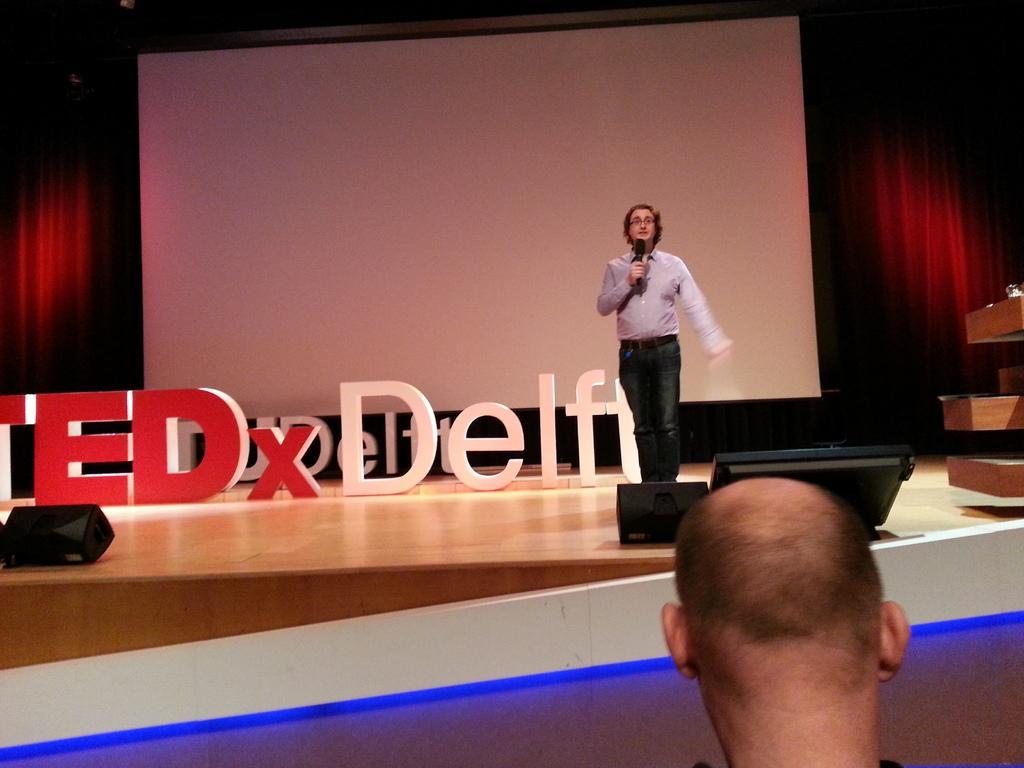Please provide a concise description of this image. In the image there is a man holding a mic standing on stage with lights in front of him and behind him there is a screen, in the front there is a bald headed man visible. 